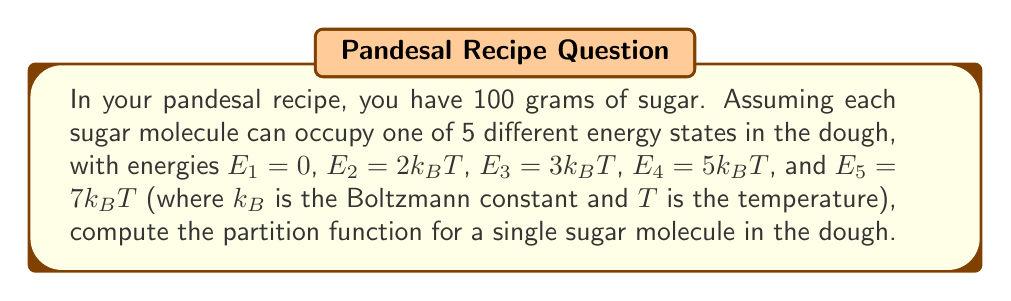Could you help me with this problem? To solve this problem, let's follow these steps:

1) The partition function $Z$ for a single particle in a system with discrete energy levels is given by:

   $$Z = \sum_i e^{-\beta E_i}$$

   where $\beta = \frac{1}{k_BT}$ and $E_i$ are the possible energy states.

2) We have 5 energy states:
   $E_1 = 0$
   $E_2 = 2k_BT$
   $E_3 = 3k_BT$
   $E_4 = 5k_BT$
   $E_5 = 7k_BT$

3) Let's calculate each term:
   
   For $E_1$: $e^{-\beta E_1} = e^{-\beta \cdot 0} = 1$
   
   For $E_2$: $e^{-\beta E_2} = e^{-\beta \cdot 2k_BT} = e^{-2}$
   
   For $E_3$: $e^{-\beta E_3} = e^{-\beta \cdot 3k_BT} = e^{-3}$
   
   For $E_4$: $e^{-\beta E_4} = e^{-\beta \cdot 5k_BT} = e^{-5}$
   
   For $E_5$: $e^{-\beta E_5} = e^{-\beta \cdot 7k_BT} = e^{-7}$

4) Now, we sum all these terms:

   $$Z = 1 + e^{-2} + e^{-3} + e^{-5} + e^{-7}$$

This is the partition function for a single sugar molecule in your pandesal dough.
Answer: $Z = 1 + e^{-2} + e^{-3} + e^{-5} + e^{-7}$ 